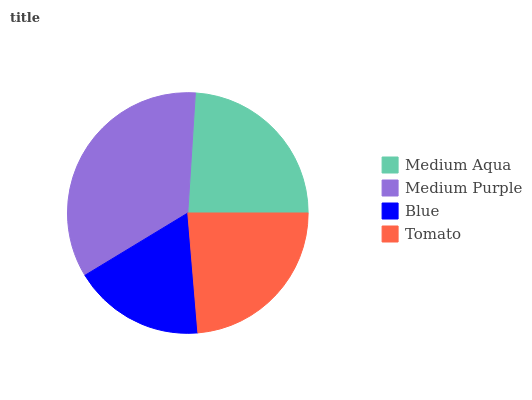Is Blue the minimum?
Answer yes or no. Yes. Is Medium Purple the maximum?
Answer yes or no. Yes. Is Medium Purple the minimum?
Answer yes or no. No. Is Blue the maximum?
Answer yes or no. No. Is Medium Purple greater than Blue?
Answer yes or no. Yes. Is Blue less than Medium Purple?
Answer yes or no. Yes. Is Blue greater than Medium Purple?
Answer yes or no. No. Is Medium Purple less than Blue?
Answer yes or no. No. Is Medium Aqua the high median?
Answer yes or no. Yes. Is Tomato the low median?
Answer yes or no. Yes. Is Tomato the high median?
Answer yes or no. No. Is Medium Aqua the low median?
Answer yes or no. No. 